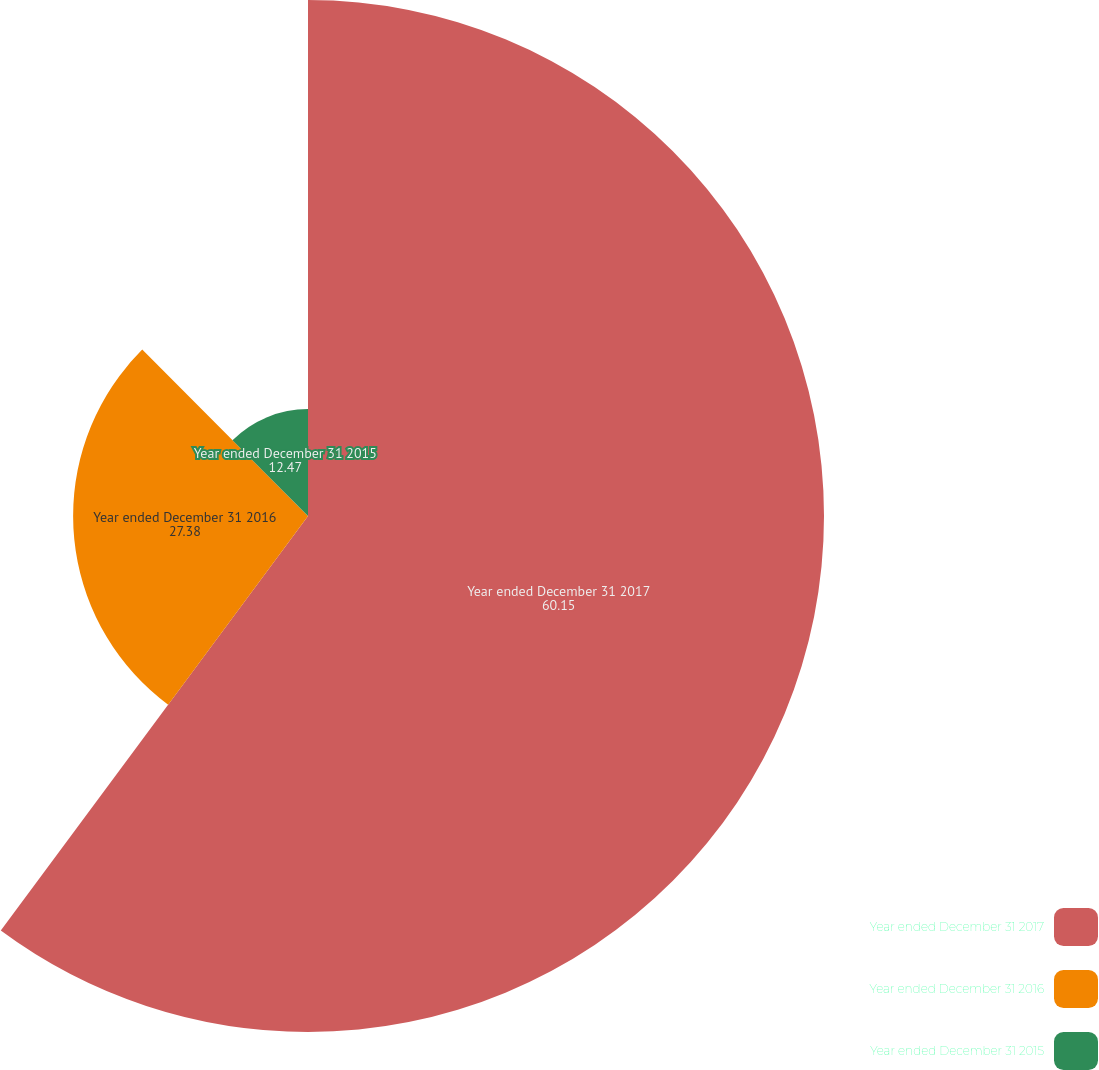Convert chart to OTSL. <chart><loc_0><loc_0><loc_500><loc_500><pie_chart><fcel>Year ended December 31 2017<fcel>Year ended December 31 2016<fcel>Year ended December 31 2015<nl><fcel>60.15%<fcel>27.38%<fcel>12.47%<nl></chart> 